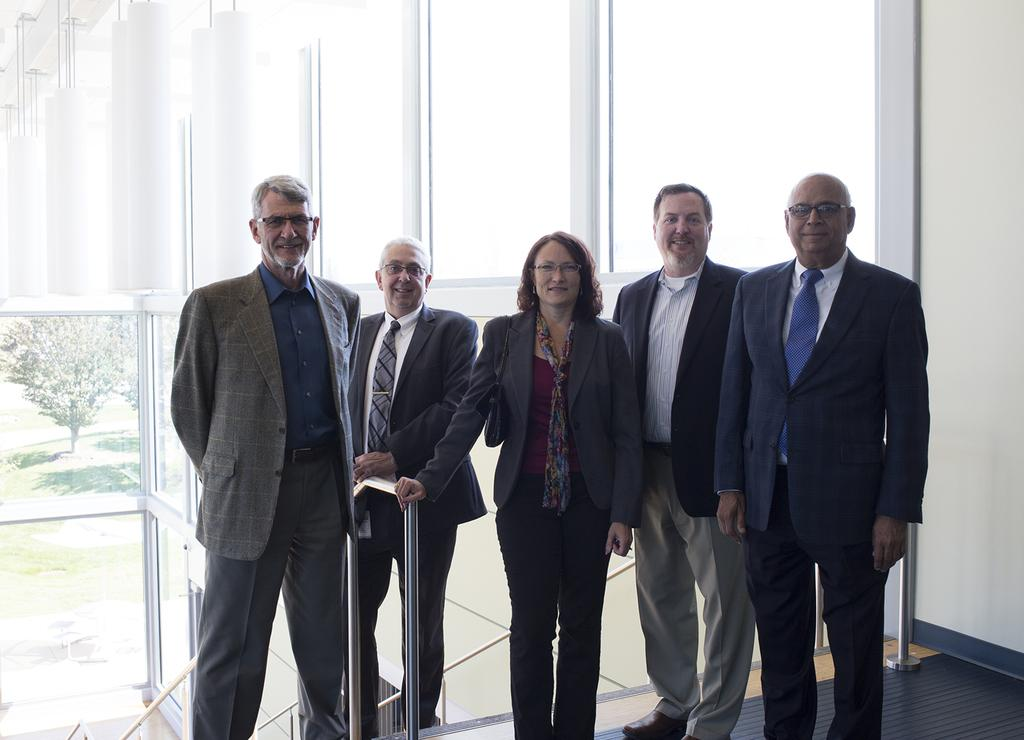What is present in the image? There are people standing in the image. What can be seen on the right side of the image? There is a white-colored wall on the right side of the image. What type of rail is visible in the image? There is no rail present in the image. What type of cloth is draped over the people in the image? There is no cloth draped over the people in the image. 